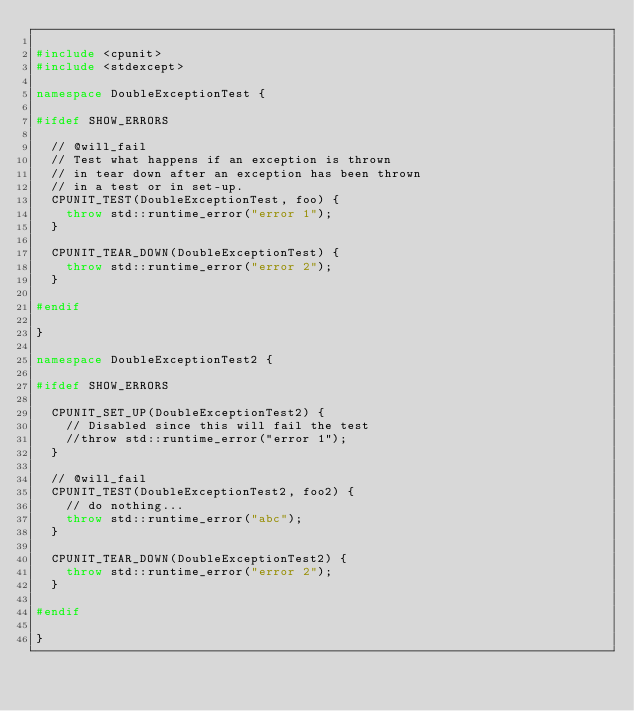<code> <loc_0><loc_0><loc_500><loc_500><_C++_>
#include <cpunit>
#include <stdexcept>

namespace DoubleExceptionTest {

#ifdef SHOW_ERRORS

  // @will_fail
  // Test what happens if an exception is thrown
  // in tear down after an exception has been thrown
  // in a test or in set-up.
  CPUNIT_TEST(DoubleExceptionTest, foo) {
    throw std::runtime_error("error 1");
  }

  CPUNIT_TEAR_DOWN(DoubleExceptionTest) {
    throw std::runtime_error("error 2");
  }

#endif

}

namespace DoubleExceptionTest2 {

#ifdef SHOW_ERRORS

  CPUNIT_SET_UP(DoubleExceptionTest2) {
    // Disabled since this will fail the test
    //throw std::runtime_error("error 1");
  }

  // @will_fail
  CPUNIT_TEST(DoubleExceptionTest2, foo2) {
    // do nothing...
    throw std::runtime_error("abc");
  }

  CPUNIT_TEAR_DOWN(DoubleExceptionTest2) {
    throw std::runtime_error("error 2");
  }

#endif

}
</code> 